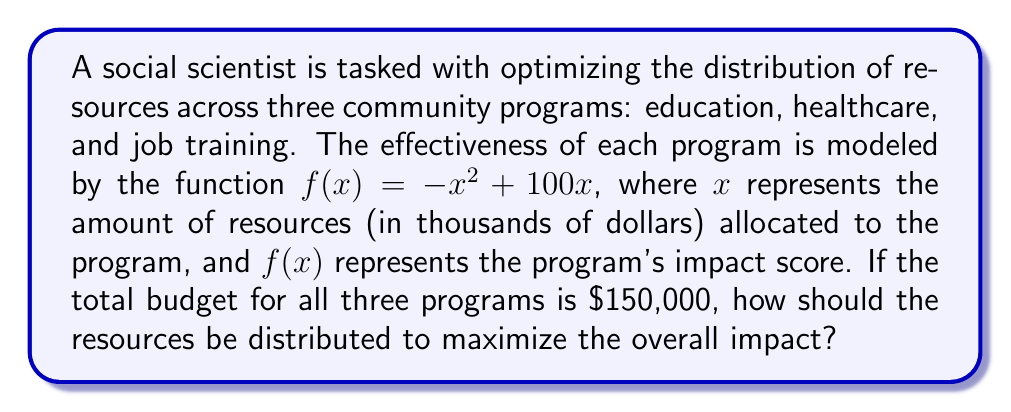Give your solution to this math problem. To solve this problem, we need to maximize the sum of the impact scores for all three programs, subject to the constraint that the total budget is $150,000. Let's approach this step-by-step:

1) Let $x$, $y$, and $z$ represent the resources (in thousands of dollars) allocated to education, healthcare, and job training programs respectively.

2) Our objective function is:
   $$ F(x,y,z) = f(x) + f(y) + f(z) = (-x^2 + 100x) + (-y^2 + 100y) + (-z^2 + 100z) $$

3) Our constraint is:
   $$ x + y + z = 150 $$

4) To maximize F subject to this constraint, we can use the method of Lagrange multipliers. We form the Lagrangian:
   $$ L(x,y,z,\lambda) = (-x^2 + 100x) + (-y^2 + 100y) + (-z^2 + 100z) + \lambda(150 - x - y - z) $$

5) We then set the partial derivatives equal to zero:
   $$ \frac{\partial L}{\partial x} = -2x + 100 - \lambda = 0 $$
   $$ \frac{\partial L}{\partial y} = -2y + 100 - \lambda = 0 $$
   $$ \frac{\partial L}{\partial z} = -2z + 100 - \lambda = 0 $$
   $$ \frac{\partial L}{\partial \lambda} = 150 - x - y - z = 0 $$

6) From the first three equations, we can see that $x = y = z$. Let's call this common value $a$.

7) Substituting into the fourth equation:
   $$ 150 - 3a = 0 $$
   $$ a = 50 $$

8) Therefore, the optimal distribution is to allocate $50,000 to each program.

9) We can verify this is a maximum by checking the second derivatives, which are negative, confirming a local maximum.
Answer: The optimal distribution is to allocate $50,000 to each of the three programs: education, healthcare, and job training. 